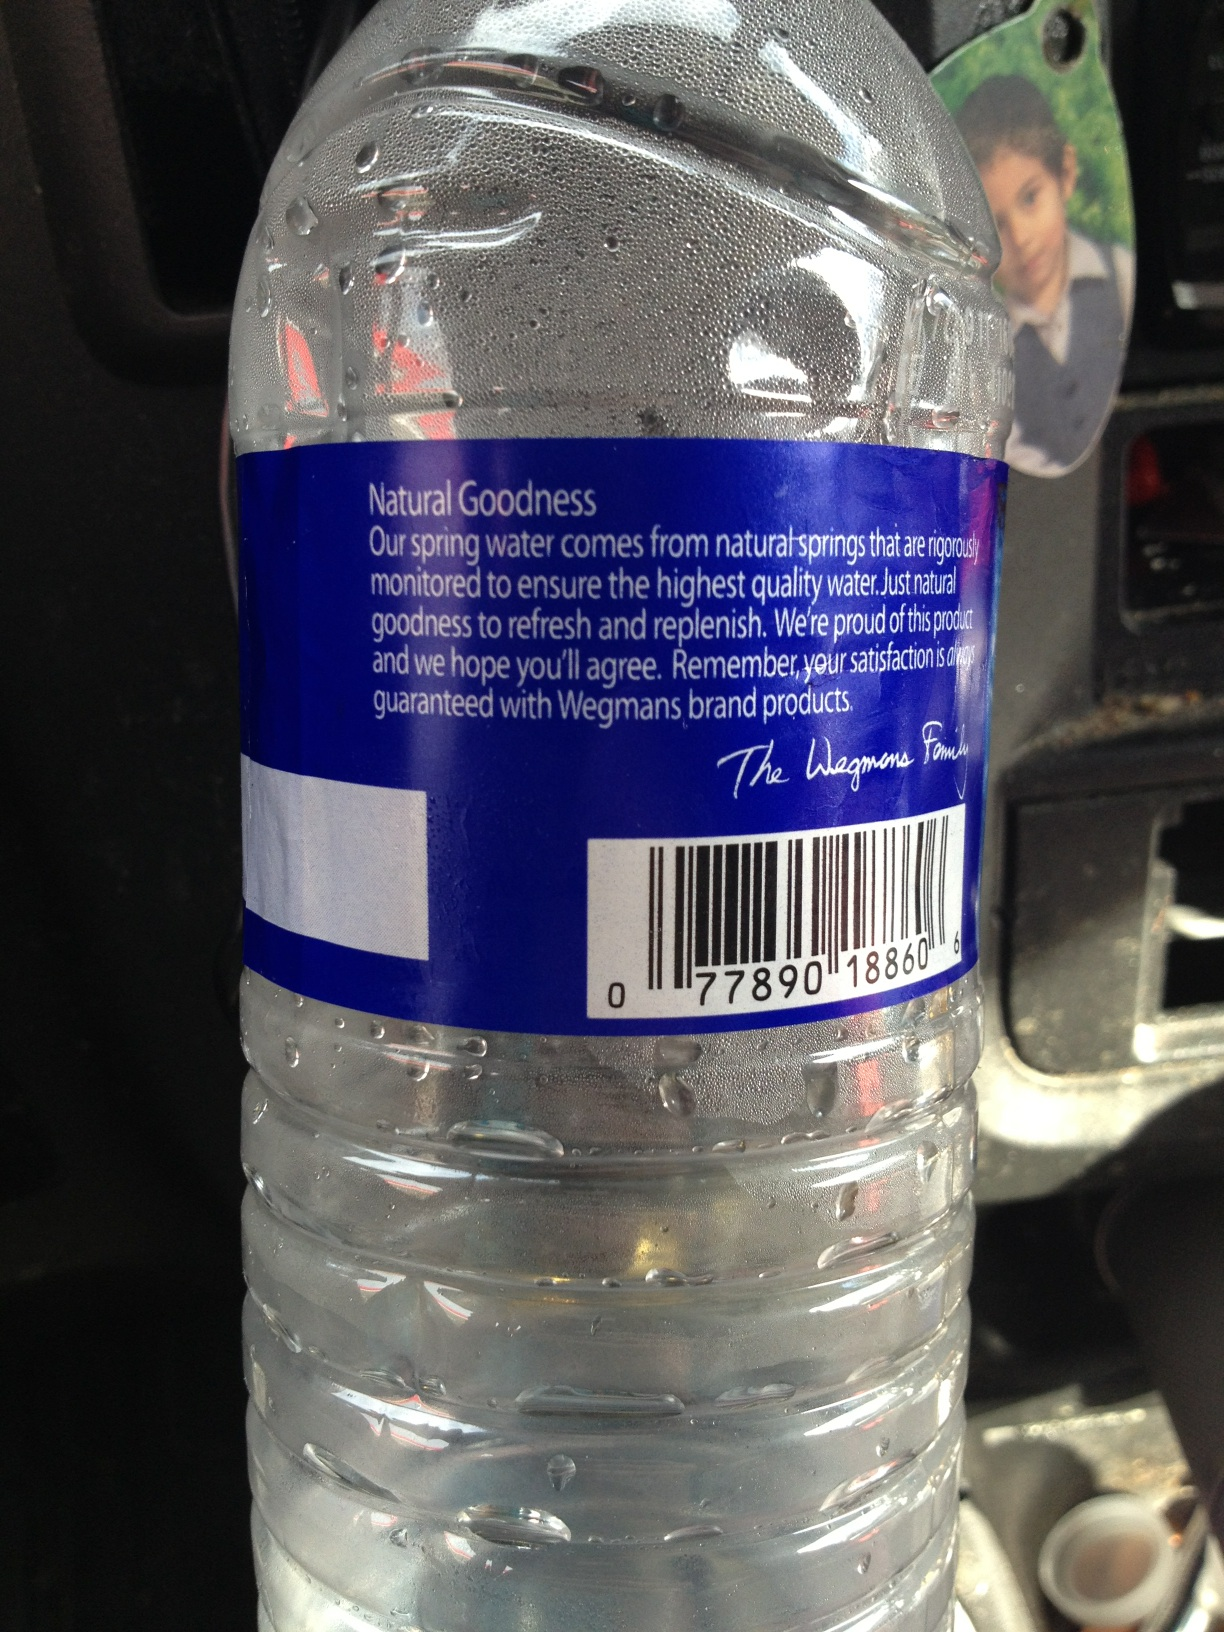Can you tell me more about the quality control mentioned on the label? Absolutely! The label mentions that the spring water comes from natural springs that are rigorously monitored to ensure the highest quality water. This involves stringent testing and quality checks to maintain purity and freshness. 